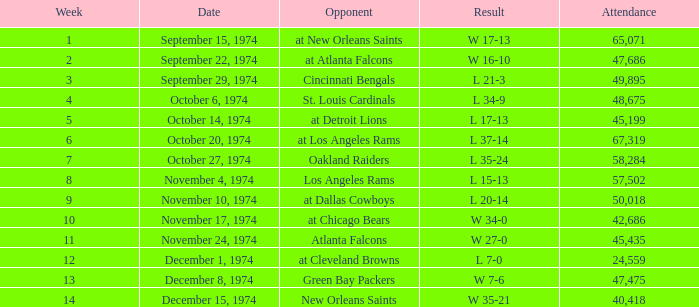Can you parse all the data within this table? {'header': ['Week', 'Date', 'Opponent', 'Result', 'Attendance'], 'rows': [['1', 'September 15, 1974', 'at New Orleans Saints', 'W 17-13', '65,071'], ['2', 'September 22, 1974', 'at Atlanta Falcons', 'W 16-10', '47,686'], ['3', 'September 29, 1974', 'Cincinnati Bengals', 'L 21-3', '49,895'], ['4', 'October 6, 1974', 'St. Louis Cardinals', 'L 34-9', '48,675'], ['5', 'October 14, 1974', 'at Detroit Lions', 'L 17-13', '45,199'], ['6', 'October 20, 1974', 'at Los Angeles Rams', 'L 37-14', '67,319'], ['7', 'October 27, 1974', 'Oakland Raiders', 'L 35-24', '58,284'], ['8', 'November 4, 1974', 'Los Angeles Rams', 'L 15-13', '57,502'], ['9', 'November 10, 1974', 'at Dallas Cowboys', 'L 20-14', '50,018'], ['10', 'November 17, 1974', 'at Chicago Bears', 'W 34-0', '42,686'], ['11', 'November 24, 1974', 'Atlanta Falcons', 'W 27-0', '45,435'], ['12', 'December 1, 1974', 'at Cleveland Browns', 'L 7-0', '24,559'], ['13', 'December 8, 1974', 'Green Bay Packers', 'W 7-6', '47,475'], ['14', 'December 15, 1974', 'New Orleans Saints', 'W 35-21', '40,418']]} What was the typical attendance at atlanta falcons' games? 47686.0. 